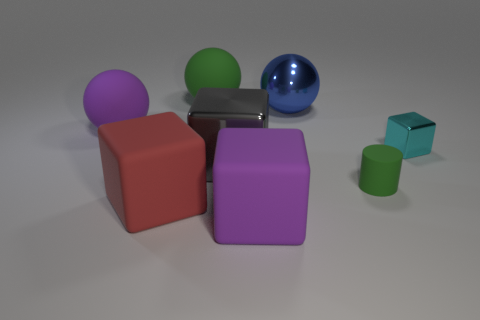Subtract all large purple rubber cubes. How many cubes are left? 3 Subtract all cyan cubes. How many cubes are left? 3 Add 2 blue things. How many objects exist? 10 Subtract all yellow cubes. Subtract all gray cylinders. How many cubes are left? 4 Subtract all cylinders. How many objects are left? 7 Add 3 small green cylinders. How many small green cylinders exist? 4 Subtract 1 purple balls. How many objects are left? 7 Subtract all big cyan metallic objects. Subtract all small shiny objects. How many objects are left? 7 Add 3 purple objects. How many purple objects are left? 5 